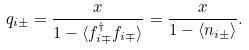<formula> <loc_0><loc_0><loc_500><loc_500>q _ { i \pm } = \frac { x } { 1 - \langle f _ { i \mp } ^ { \dagger } f _ { i \mp } \rangle } = \frac { x } { 1 - \langle n _ { i \pm } \rangle } .</formula> 